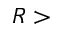<formula> <loc_0><loc_0><loc_500><loc_500>R ></formula> 